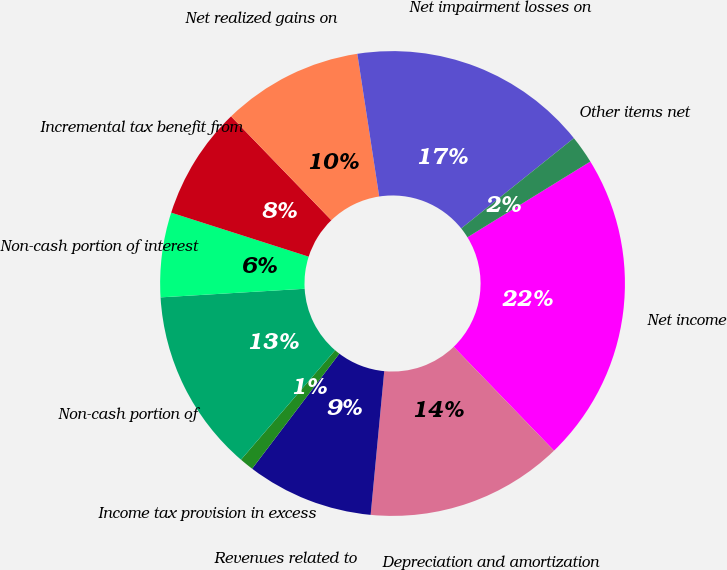Convert chart to OTSL. <chart><loc_0><loc_0><loc_500><loc_500><pie_chart><fcel>Net income<fcel>Depreciation and amortization<fcel>Revenues related to<fcel>Income tax provision in excess<fcel>Non-cash portion of<fcel>Non-cash portion of interest<fcel>Incremental tax benefit from<fcel>Net realized gains on<fcel>Net impairment losses on<fcel>Other items net<nl><fcel>21.56%<fcel>13.72%<fcel>8.82%<fcel>0.98%<fcel>12.74%<fcel>5.88%<fcel>7.84%<fcel>9.8%<fcel>16.66%<fcel>1.96%<nl></chart> 